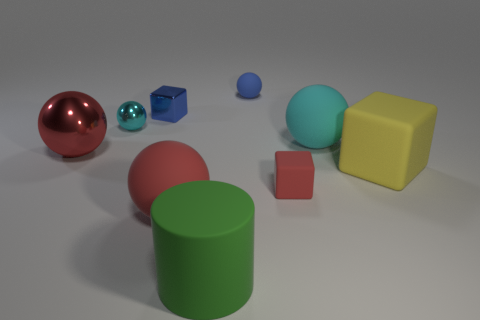If this image were a part of a children's learning book, what might be a good question to ask to engage young viewers? For a children's learning book, a good question might be: 'Can you count all the objects and name their colors?' This can help children practice counting and color recognition in an engaging, visual way. 